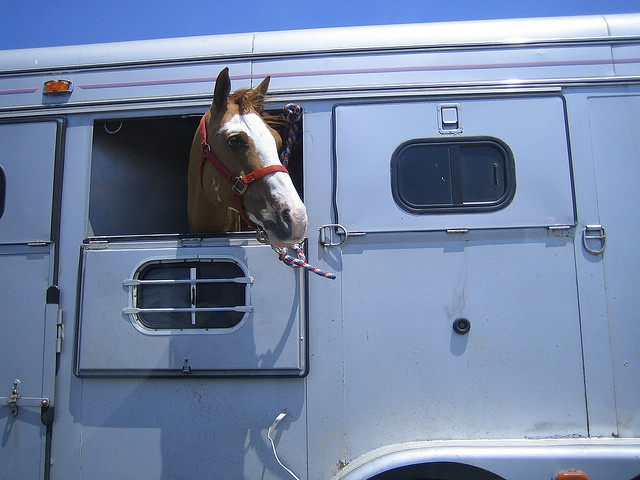Describe the objects in this image and their specific colors. I can see truck in darkgray, gray, and blue tones and horse in blue, black, white, gray, and maroon tones in this image. 